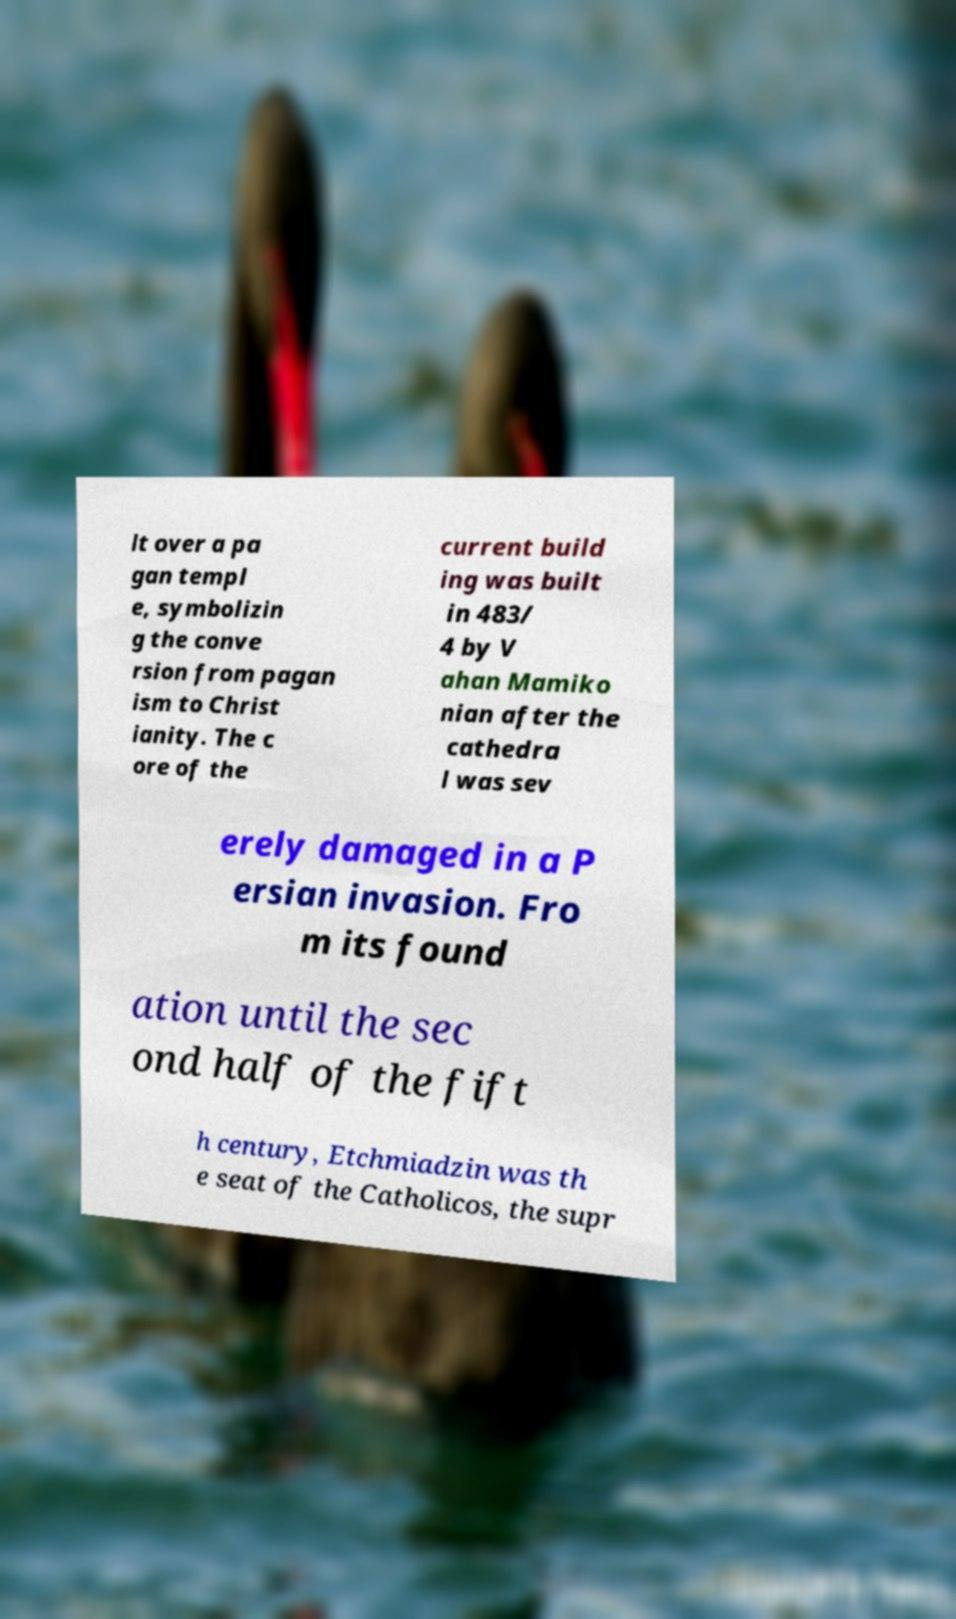Please identify and transcribe the text found in this image. lt over a pa gan templ e, symbolizin g the conve rsion from pagan ism to Christ ianity. The c ore of the current build ing was built in 483/ 4 by V ahan Mamiko nian after the cathedra l was sev erely damaged in a P ersian invasion. Fro m its found ation until the sec ond half of the fift h century, Etchmiadzin was th e seat of the Catholicos, the supr 